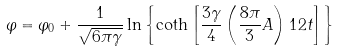<formula> <loc_0><loc_0><loc_500><loc_500>\varphi = \varphi _ { 0 } + \frac { 1 } { \sqrt { 6 \pi \gamma } } \ln \left \{ \coth \left [ \frac { 3 \gamma } { 4 } \left ( \frac { 8 \pi } { 3 } A \right ) ^ { } { 1 } 2 t \right ] \right \}</formula> 